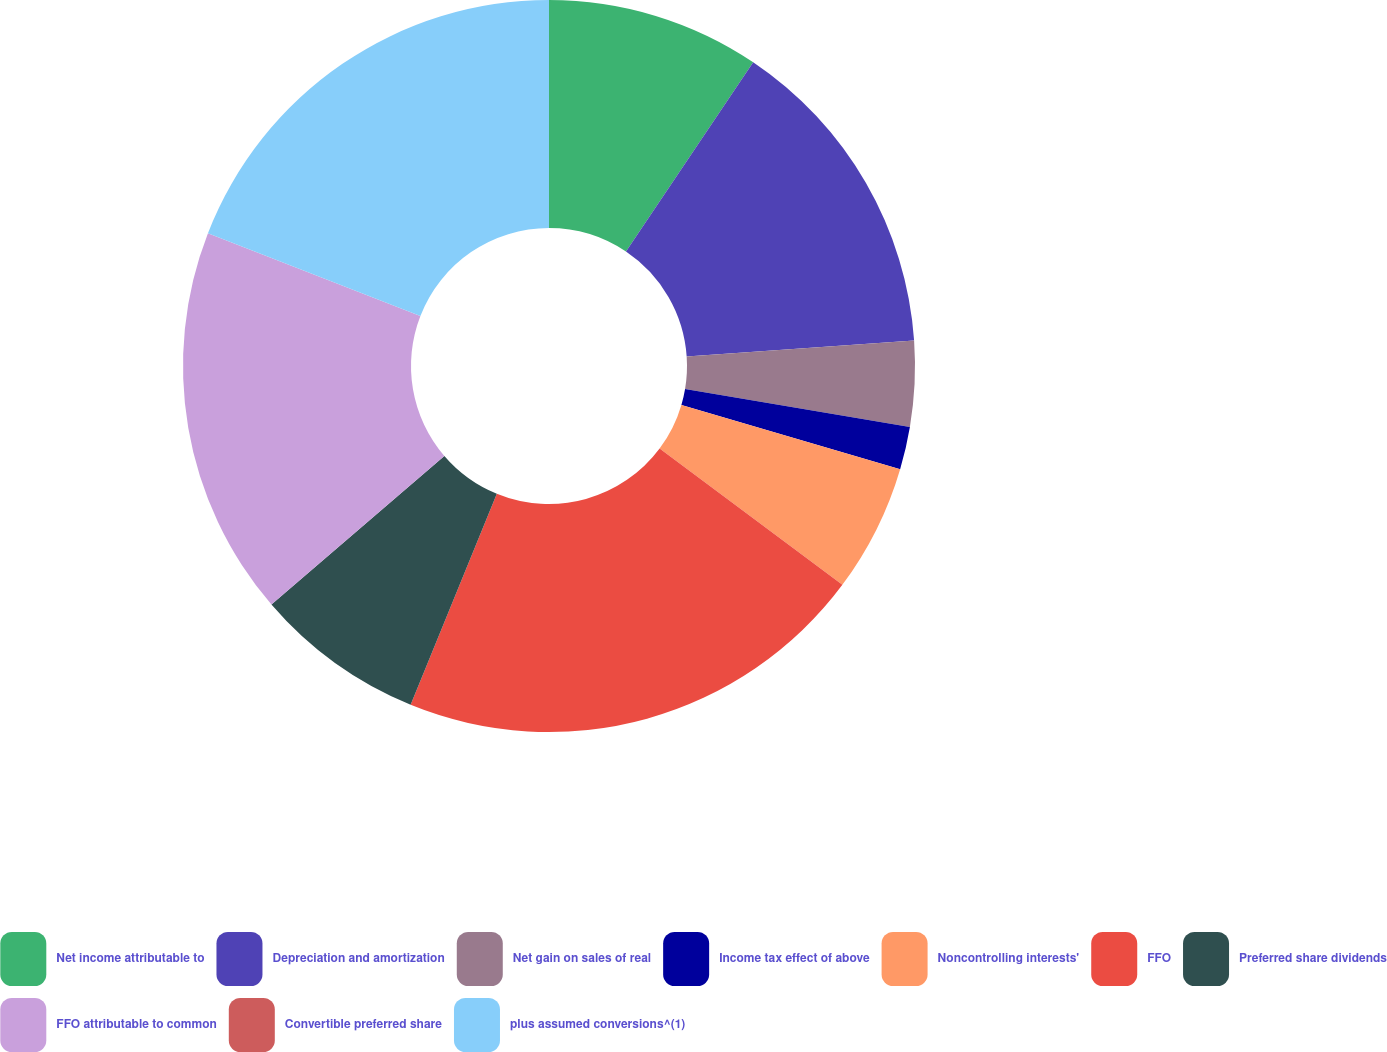Convert chart to OTSL. <chart><loc_0><loc_0><loc_500><loc_500><pie_chart><fcel>Net income attributable to<fcel>Depreciation and amortization<fcel>Net gain on sales of real<fcel>Income tax effect of above<fcel>Noncontrolling interests'<fcel>FFO<fcel>Preferred share dividends<fcel>FFO attributable to common<fcel>Convertible preferred share<fcel>plus assumed conversions^(1)<nl><fcel>9.42%<fcel>14.47%<fcel>3.77%<fcel>1.89%<fcel>5.65%<fcel>20.97%<fcel>7.53%<fcel>17.21%<fcel>0.0%<fcel>19.09%<nl></chart> 